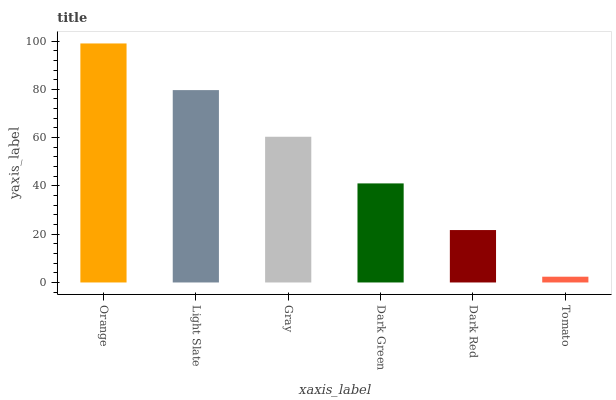Is Tomato the minimum?
Answer yes or no. Yes. Is Orange the maximum?
Answer yes or no. Yes. Is Light Slate the minimum?
Answer yes or no. No. Is Light Slate the maximum?
Answer yes or no. No. Is Orange greater than Light Slate?
Answer yes or no. Yes. Is Light Slate less than Orange?
Answer yes or no. Yes. Is Light Slate greater than Orange?
Answer yes or no. No. Is Orange less than Light Slate?
Answer yes or no. No. Is Gray the high median?
Answer yes or no. Yes. Is Dark Green the low median?
Answer yes or no. Yes. Is Orange the high median?
Answer yes or no. No. Is Dark Red the low median?
Answer yes or no. No. 